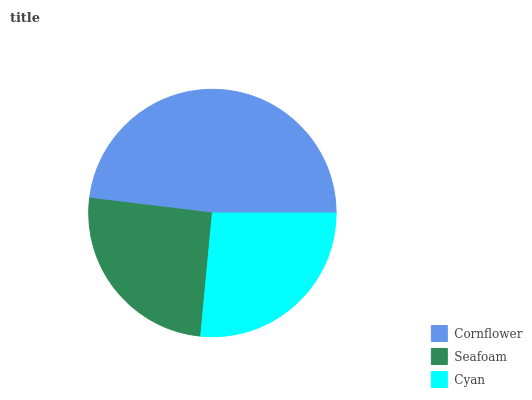Is Seafoam the minimum?
Answer yes or no. Yes. Is Cornflower the maximum?
Answer yes or no. Yes. Is Cyan the minimum?
Answer yes or no. No. Is Cyan the maximum?
Answer yes or no. No. Is Cyan greater than Seafoam?
Answer yes or no. Yes. Is Seafoam less than Cyan?
Answer yes or no. Yes. Is Seafoam greater than Cyan?
Answer yes or no. No. Is Cyan less than Seafoam?
Answer yes or no. No. Is Cyan the high median?
Answer yes or no. Yes. Is Cyan the low median?
Answer yes or no. Yes. Is Cornflower the high median?
Answer yes or no. No. Is Seafoam the low median?
Answer yes or no. No. 